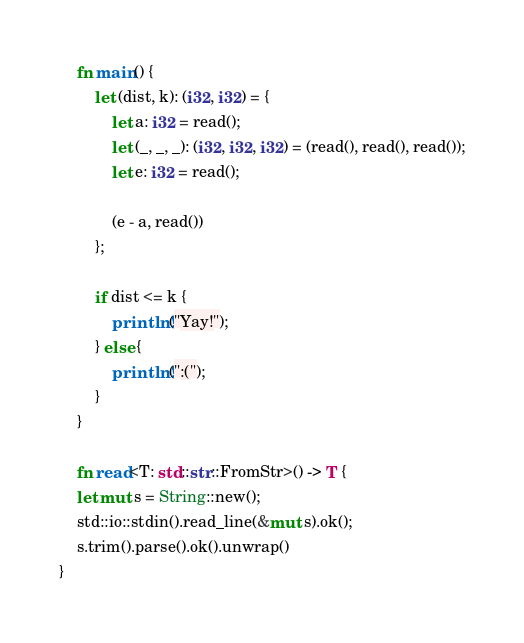<code> <loc_0><loc_0><loc_500><loc_500><_Rust_>    fn main() {
        let (dist, k): (i32, i32) = {
            let a: i32 = read();
            let (_, _, _): (i32, i32, i32) = (read(), read(), read());
            let e: i32 = read();
     
            (e - a, read())
        };
     
        if dist <= k {
            println!("Yay!");
        } else {
            println!(":(");
        }
    }
    
    fn read<T: std::str::FromStr>() -> T {
    let mut s = String::new();
    std::io::stdin().read_line(&mut s).ok();
    s.trim().parse().ok().unwrap()
}
</code> 